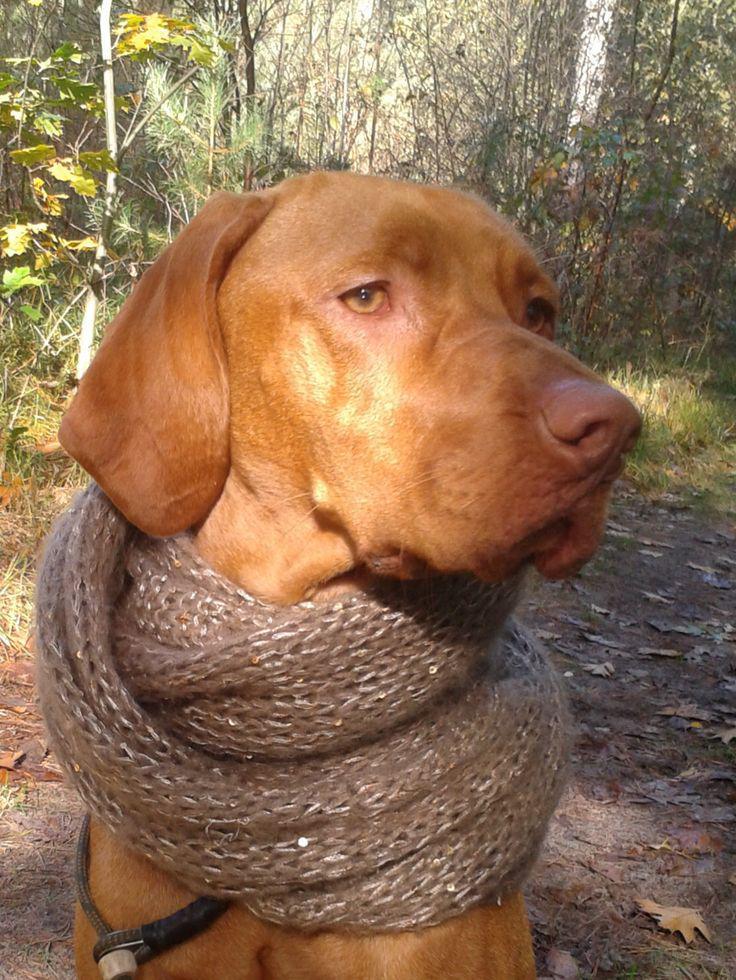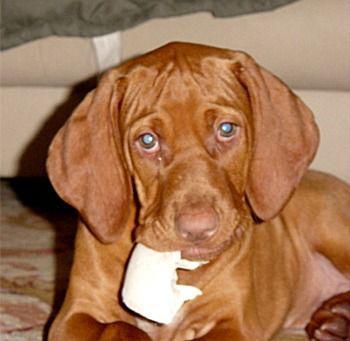The first image is the image on the left, the second image is the image on the right. Evaluate the accuracy of this statement regarding the images: "One dog is outdoors, while the other dog is indoors.". Is it true? Answer yes or no. Yes. The first image is the image on the left, the second image is the image on the right. For the images shown, is this caption "The dog in the right image is wearing a black collar." true? Answer yes or no. No. 